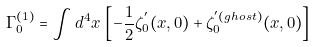Convert formula to latex. <formula><loc_0><loc_0><loc_500><loc_500>\Gamma _ { 0 } ^ { ( 1 ) } = \int d ^ { 4 } x \, \left [ - { \frac { 1 } { 2 } } \zeta _ { 0 } ^ { ^ { \prime } } ( x , 0 ) + \zeta _ { 0 } ^ { ^ { \prime } ( g h o s t ) } ( x , 0 ) \right ]</formula> 